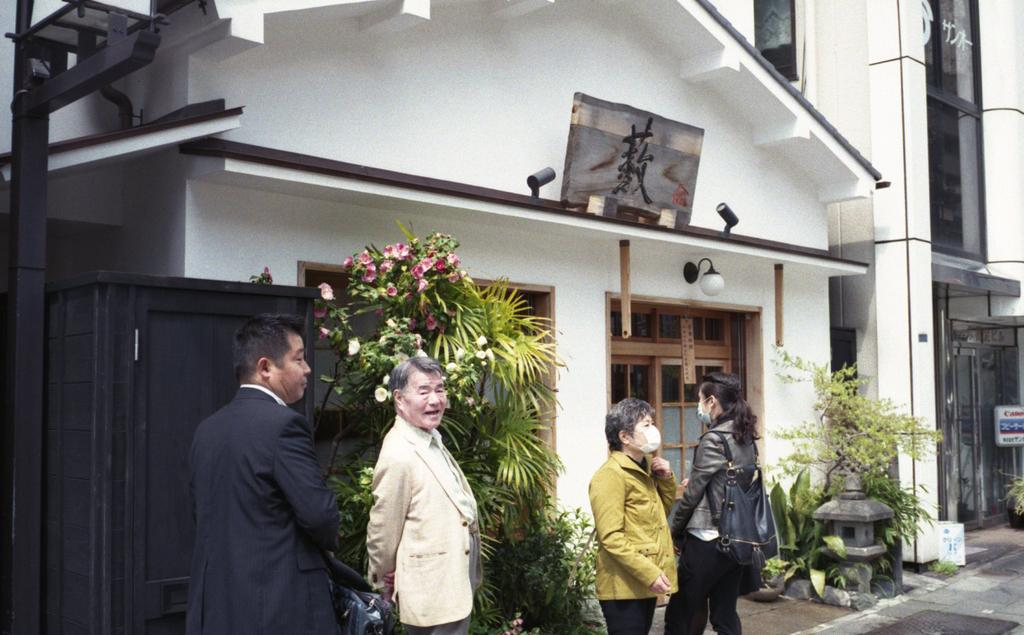How many people are present in the image? There are four persons standing on the floor in the image. What other elements can be seen in the image besides the people? There are plants, flowers, boards, and buildings in the background of the image. What type of hen can be seen laying eggs in the image? There is no hen or eggs present in the image; it features four people, plants, flowers, boards, and buildings in the background. 